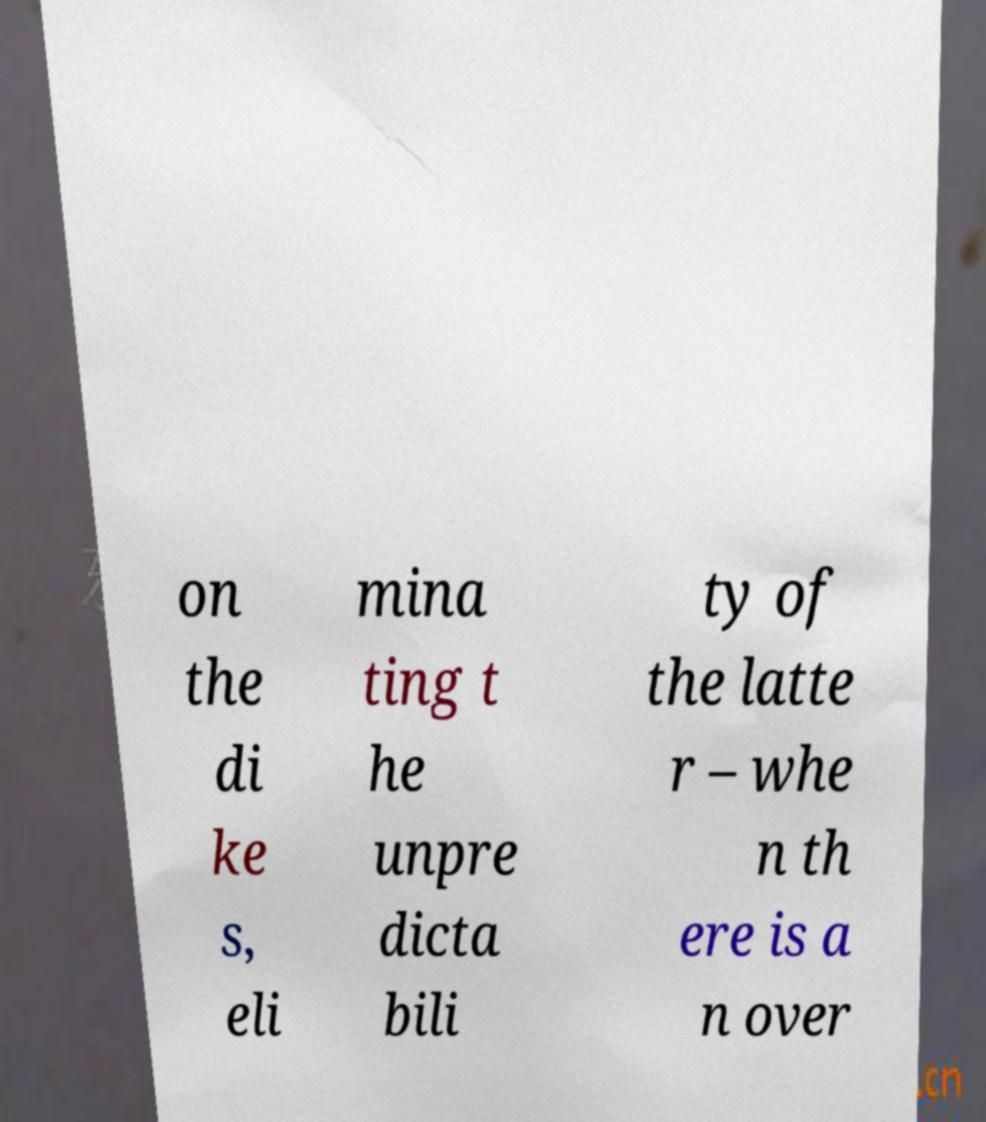Can you accurately transcribe the text from the provided image for me? on the di ke s, eli mina ting t he unpre dicta bili ty of the latte r – whe n th ere is a n over 